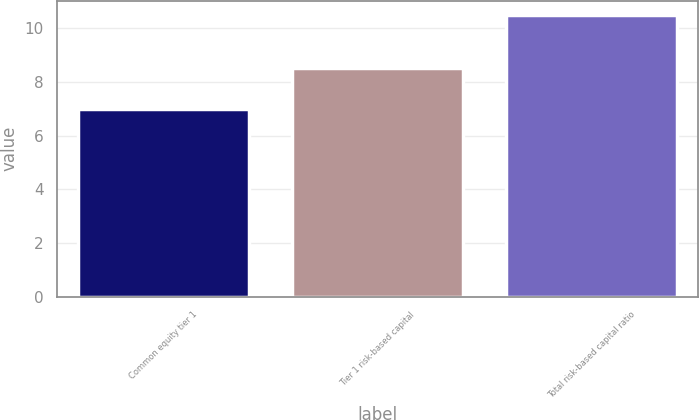<chart> <loc_0><loc_0><loc_500><loc_500><bar_chart><fcel>Common equity tier 1<fcel>Tier 1 risk-based capital<fcel>Total risk-based capital ratio<nl><fcel>7<fcel>8.5<fcel>10.5<nl></chart> 